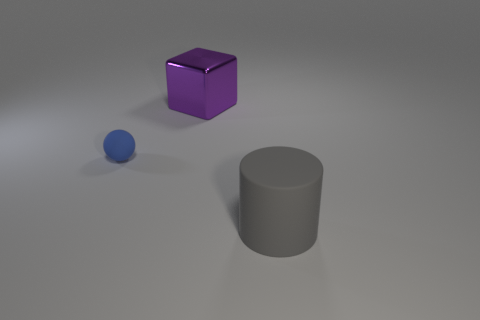Add 3 large yellow cylinders. How many objects exist? 6 Subtract all cubes. How many objects are left? 2 Add 2 big metallic blocks. How many big metallic blocks are left? 3 Add 2 blue matte things. How many blue matte things exist? 3 Subtract 0 blue cylinders. How many objects are left? 3 Subtract all red things. Subtract all big gray matte objects. How many objects are left? 2 